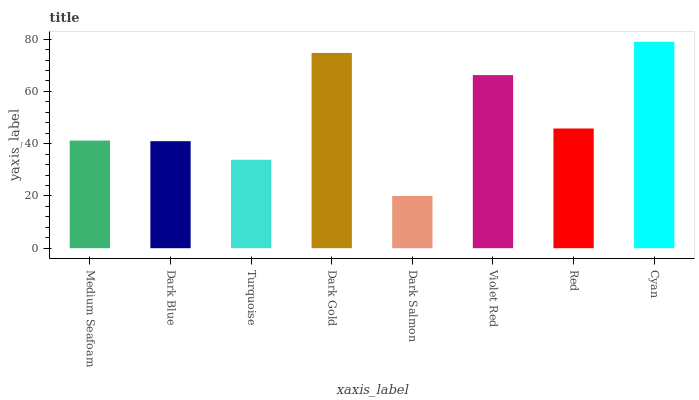Is Dark Salmon the minimum?
Answer yes or no. Yes. Is Cyan the maximum?
Answer yes or no. Yes. Is Dark Blue the minimum?
Answer yes or no. No. Is Dark Blue the maximum?
Answer yes or no. No. Is Medium Seafoam greater than Dark Blue?
Answer yes or no. Yes. Is Dark Blue less than Medium Seafoam?
Answer yes or no. Yes. Is Dark Blue greater than Medium Seafoam?
Answer yes or no. No. Is Medium Seafoam less than Dark Blue?
Answer yes or no. No. Is Red the high median?
Answer yes or no. Yes. Is Medium Seafoam the low median?
Answer yes or no. Yes. Is Medium Seafoam the high median?
Answer yes or no. No. Is Dark Salmon the low median?
Answer yes or no. No. 